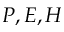Convert formula to latex. <formula><loc_0><loc_0><loc_500><loc_500>P , E , H</formula> 